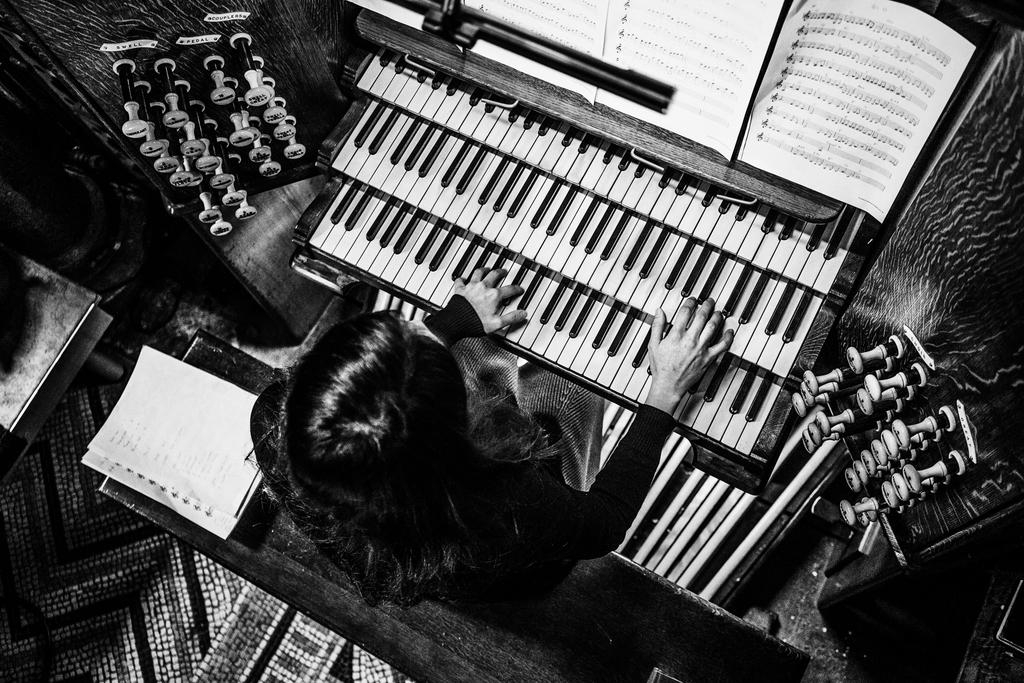Who is the main subject in the image? There is a lady in the image. What is the lady doing in the image? The lady is playing a piano. Are there any other objects or items related to the piano in the image? Yes, there are books of tubes attached to the piano. What type of jewel can be seen on the lady's finger while she is playing the piano? There is no mention of a jewel on the lady's finger in the image. 